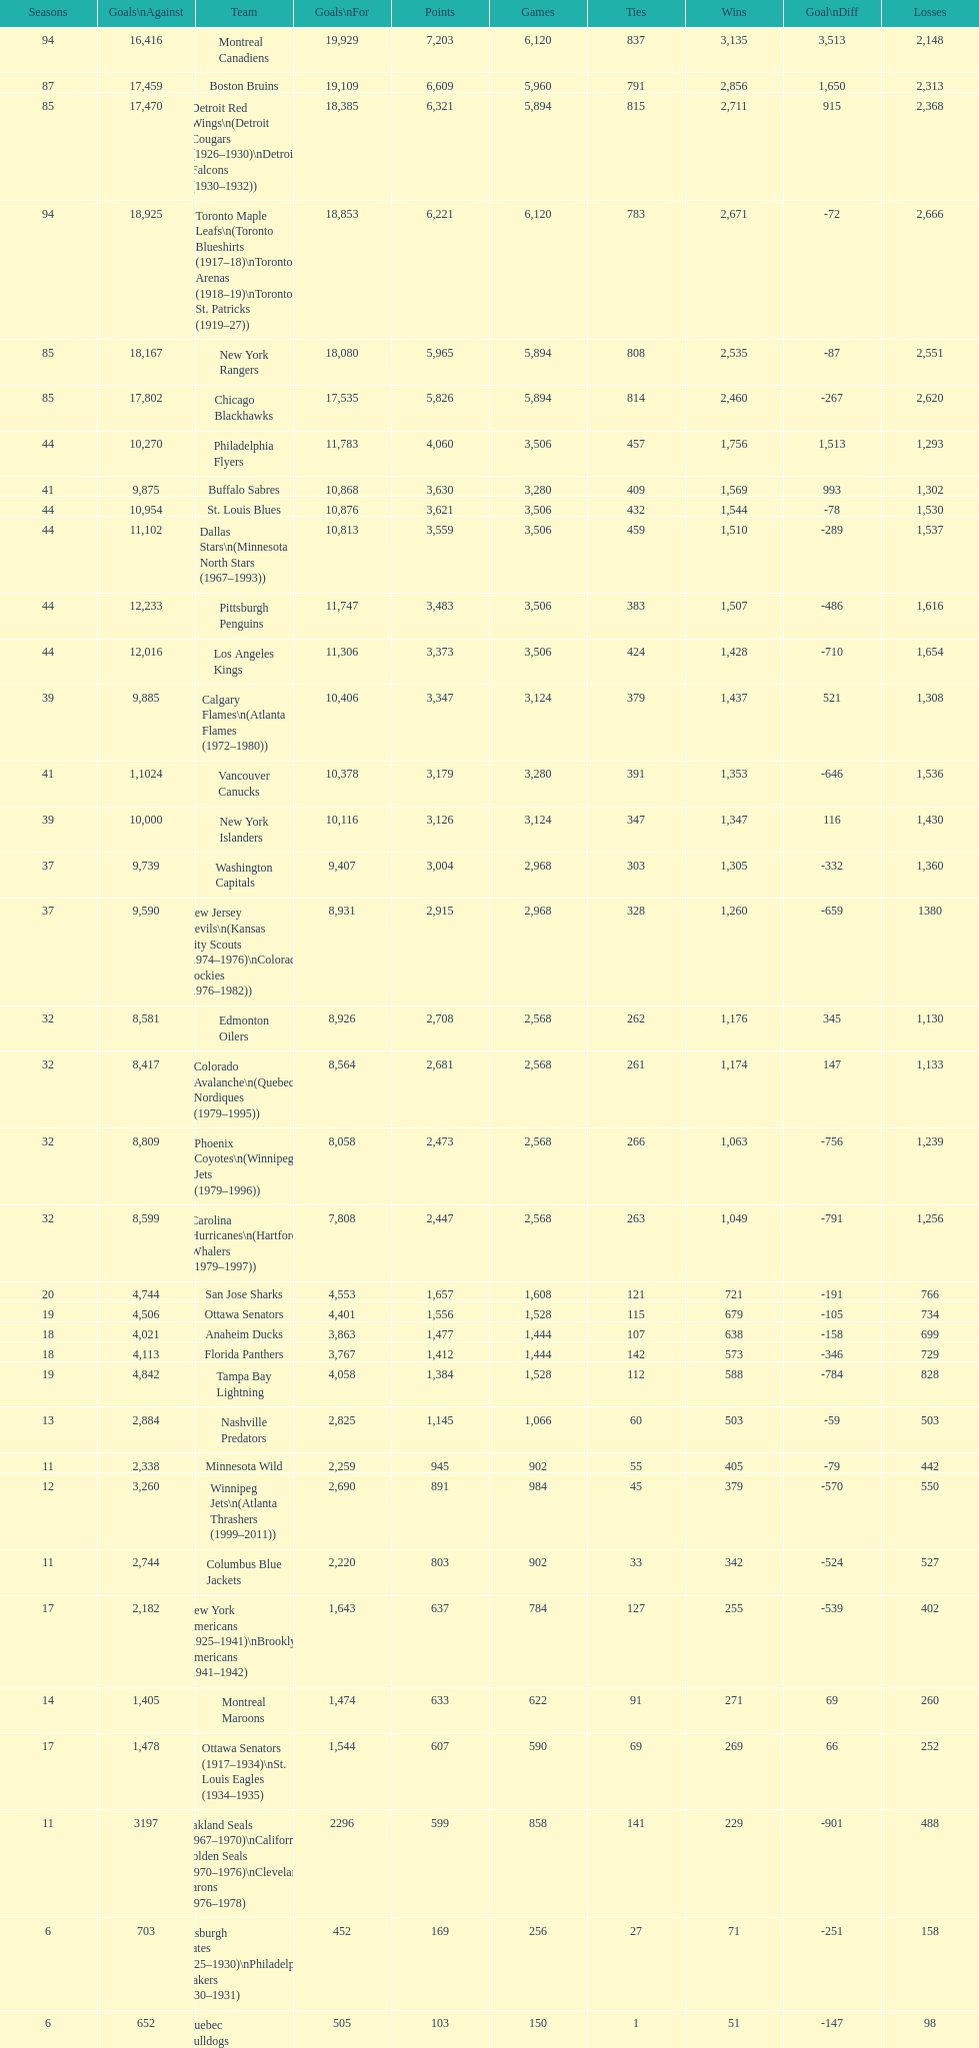How many total points has the lost angeles kings scored? 3,373. 